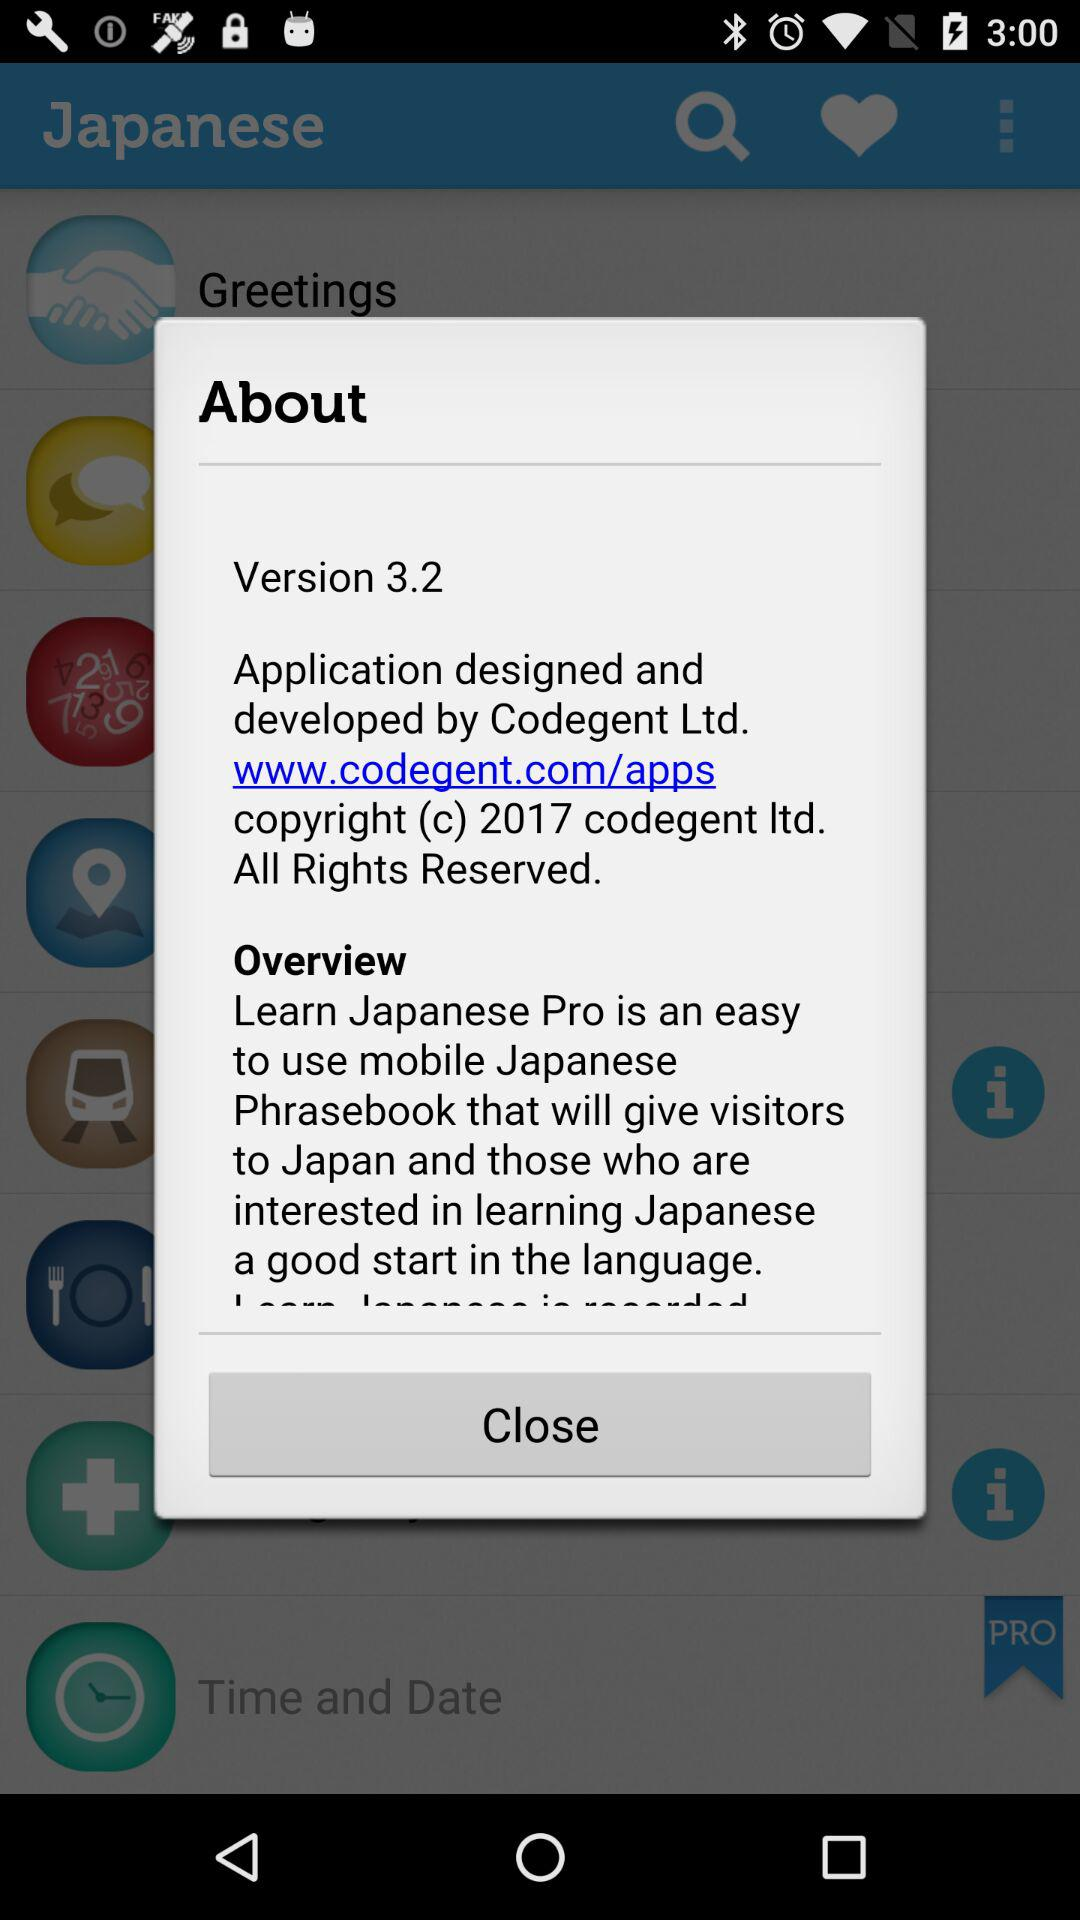What is the version of the app? The version of the app is 3.2. 